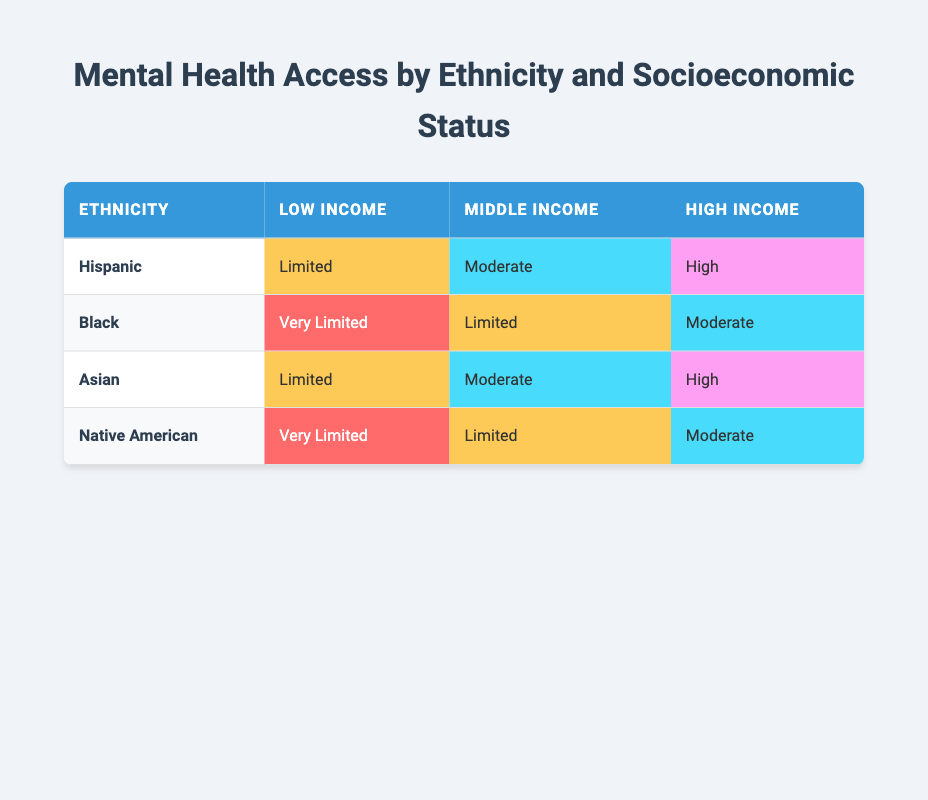What is the access level to mental health services for Hispanic individuals with low income? According to the table, Hispanic individuals with low income have "Limited" access to mental health services. This information is directly found under the "Low Income" column for the "Hispanic" row.
Answer: Limited How many groups have "Very Limited" access to mental health services? There are two groups listed in the table (Black and Native American) that have "Very Limited" access. This can be verified by looking at the "Low Income" row for these two ethnicities in the table.
Answer: 2 What is the difference in access levels to mental health services between middle-income Black and Hispanic individuals? Middle-income Black individuals have "Limited" access, while middle-income Hispanic individuals have "Moderate" access. The difference indicates that Hispanic individuals have one level higher access compared to Black individuals in this income bracket.
Answer: 1 level Is it true that all high-income groups have "High" access to mental health services? No, this statement is false. According to the table, both Hispanic and Asian individuals at high income have "High" access, but Black and Native American individuals have "Moderate" access. Therefore, not all high-income groups have "High" access.
Answer: No For which ethnic group is the access to mental health services highest at the low-income level? The ethnic group with the highest access at the low-income level is Hispanic, which has "Limited" access, while both Black and Native American have "Very Limited" access. This comparison is made by reviewing the access levels for each ethnic group within the "Low Income" category.
Answer: Hispanic 